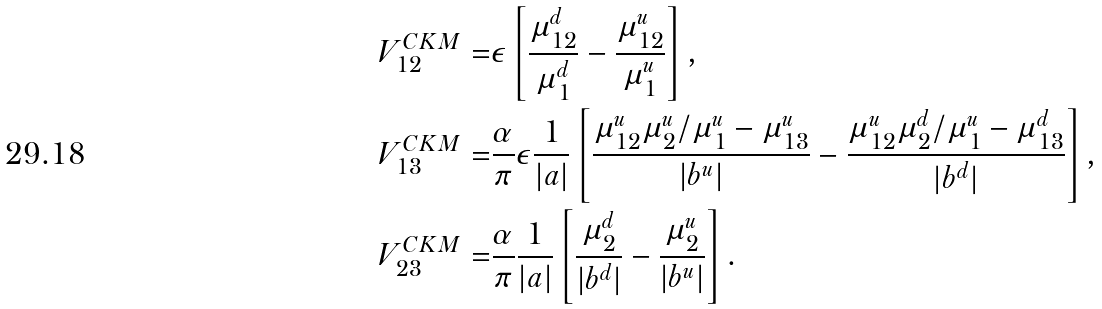<formula> <loc_0><loc_0><loc_500><loc_500>V ^ { C K M } _ { 1 2 } = & \epsilon \left [ \frac { \mu ^ { d } _ { 1 2 } } { \mu ^ { d } _ { 1 } } - \frac { \mu ^ { u } _ { 1 2 } } { \mu ^ { u } _ { 1 } } \right ] , \\ V ^ { C K M } _ { 1 3 } = & \frac { \alpha } { \pi } \epsilon \frac { 1 } { | a | } \left [ \frac { \mu ^ { u } _ { 1 2 } \mu ^ { u } _ { 2 } / \mu ^ { u } _ { 1 } - \mu ^ { u } _ { 1 3 } } { | b ^ { u } | } - \frac { \mu ^ { u } _ { 1 2 } \mu ^ { d } _ { 2 } / \mu ^ { u } _ { 1 } - \mu ^ { d } _ { 1 3 } } { | b ^ { d } | } \right ] , \\ V ^ { C K M } _ { 2 3 } = & \frac { \alpha } { \pi } \frac { 1 } { | a | } \left [ \frac { \mu ^ { d } _ { 2 } } { | b ^ { d } | } - \frac { \mu ^ { u } _ { 2 } } { | b ^ { u } | } \right ] .</formula> 